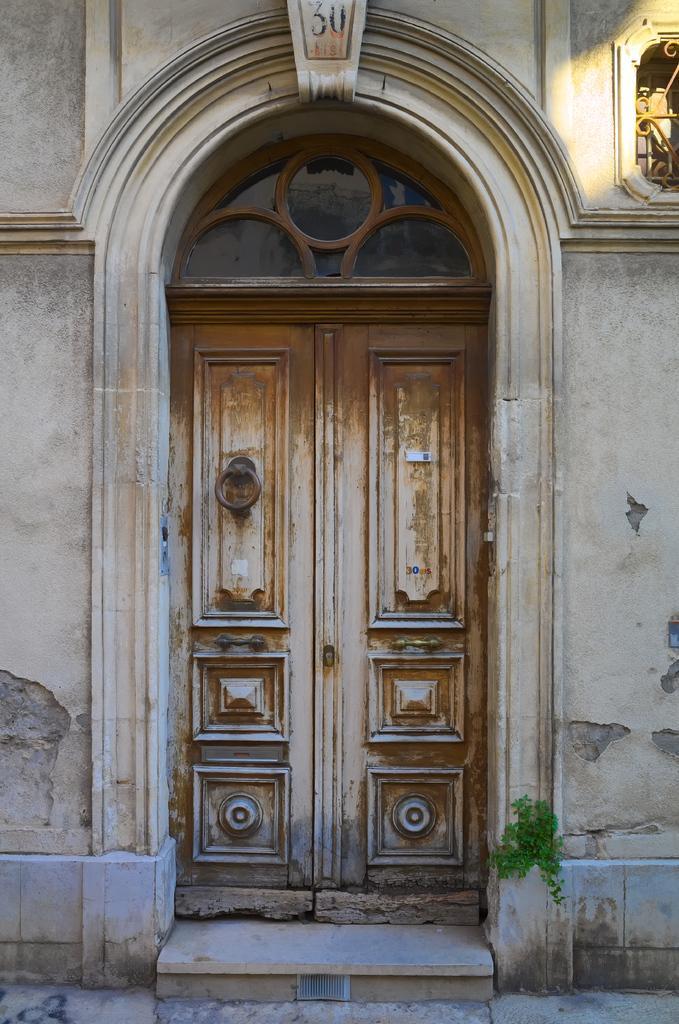In one or two sentences, can you explain what this image depicts? In this picture we can see door. Here we can see a green grass. On the top right corner there is a ventilation. On the top we can see number thirty. 